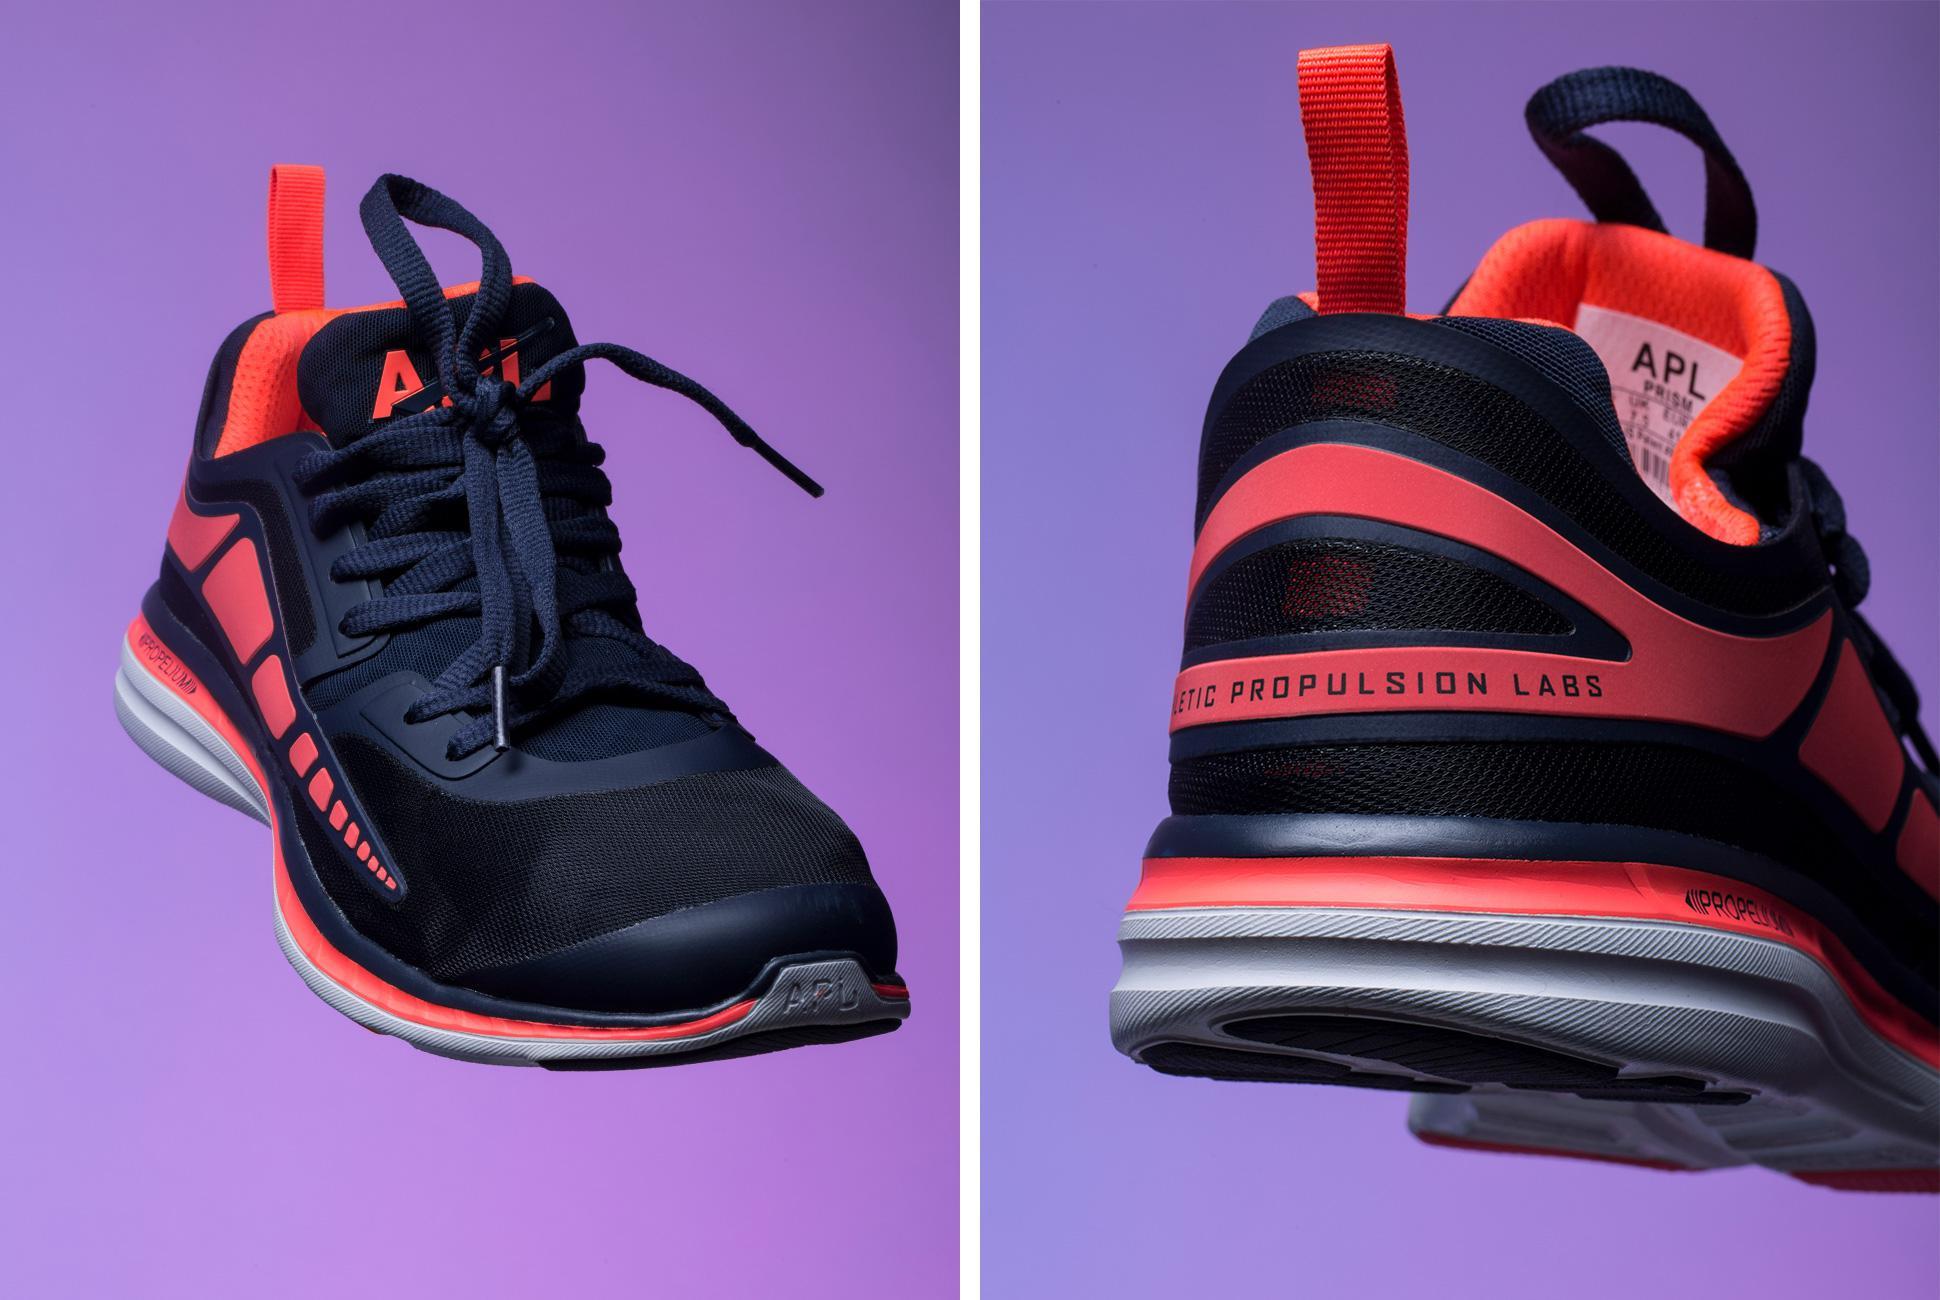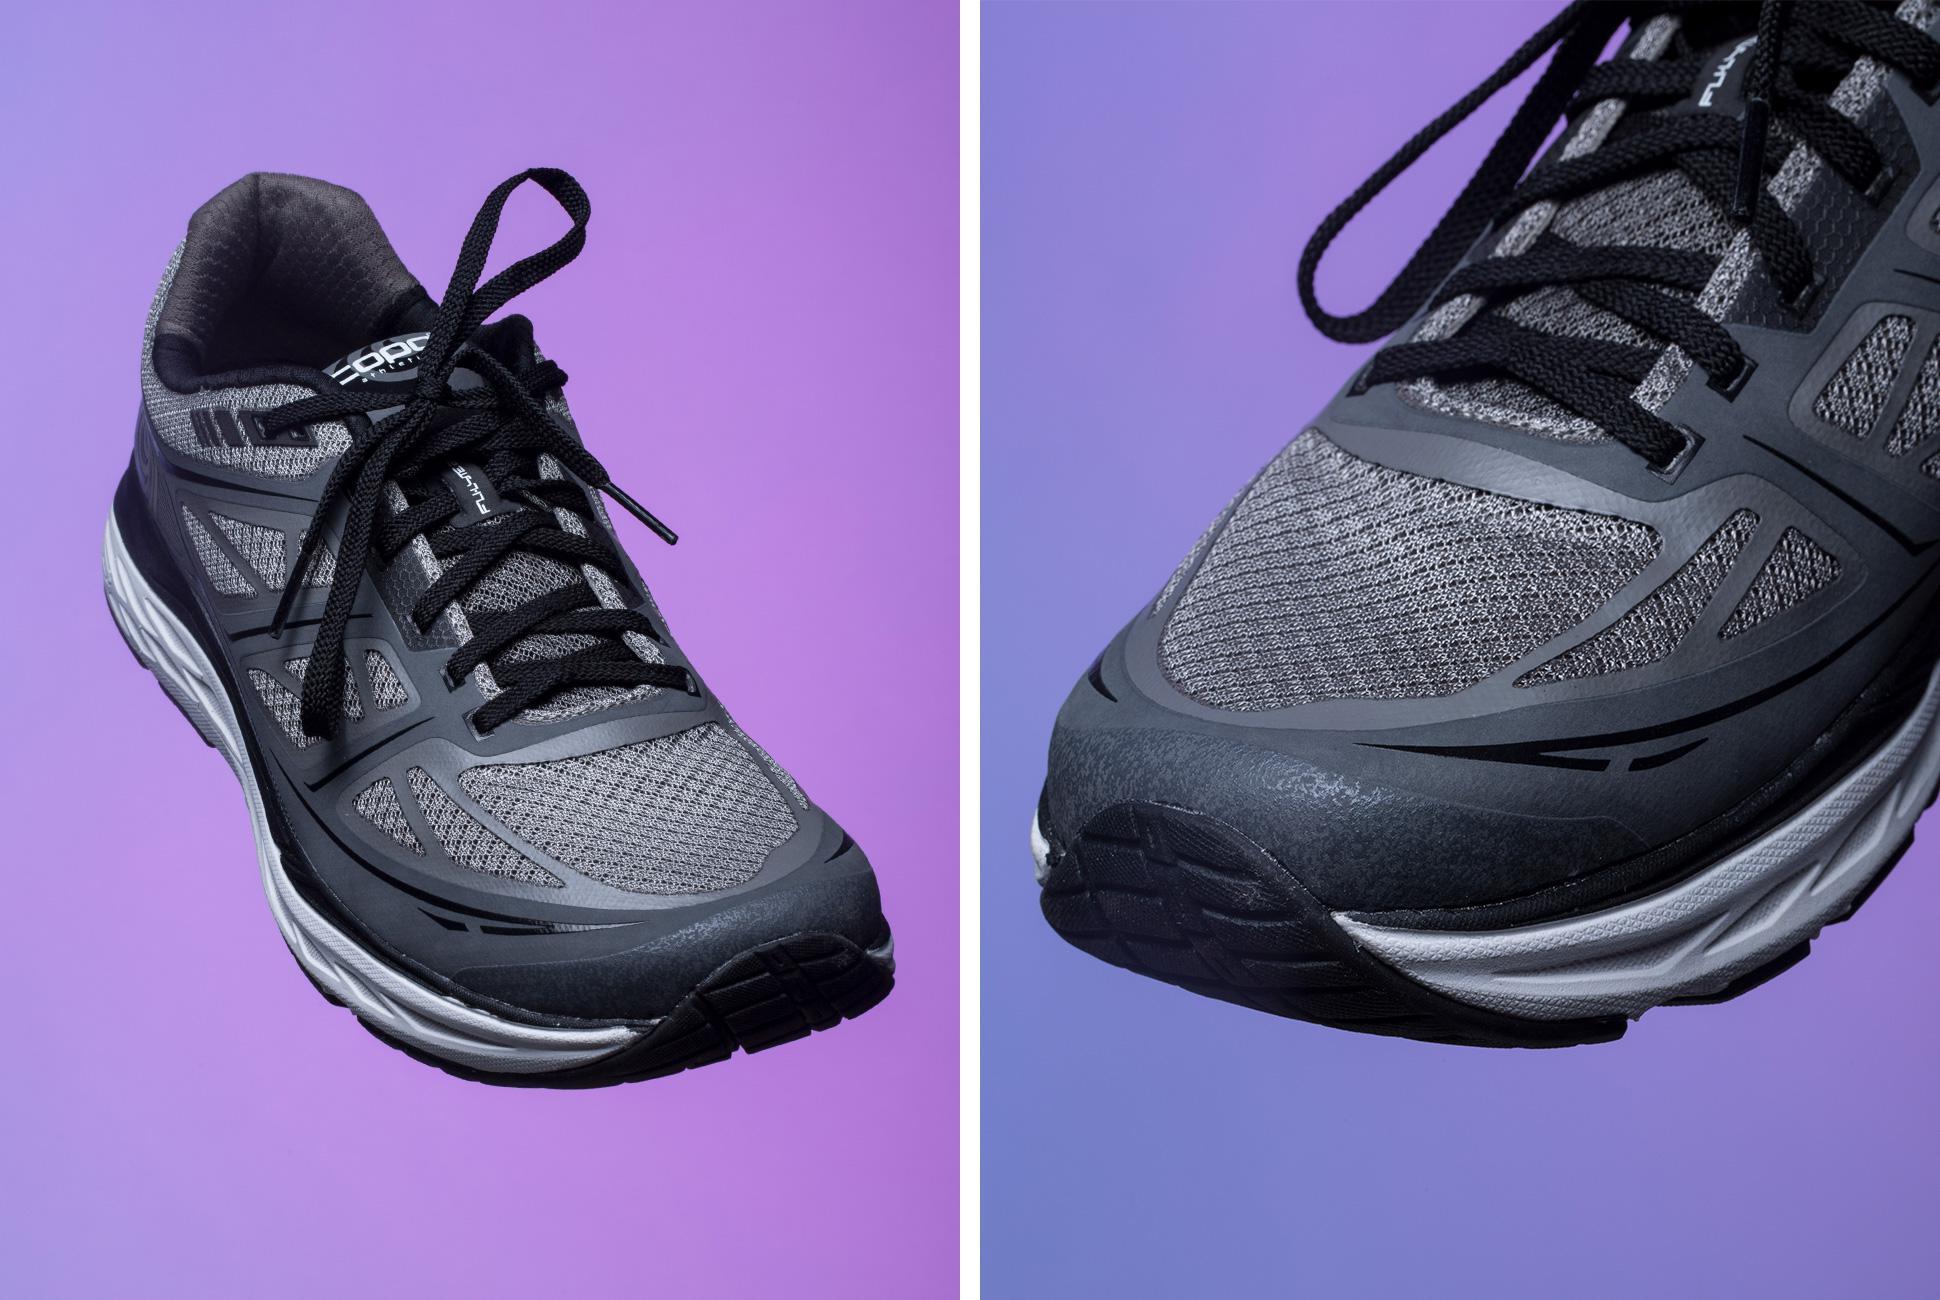The first image is the image on the left, the second image is the image on the right. Assess this claim about the two images: "No more than four sneakers are shown in total, and one sneaker is shown heel-first.". Correct or not? Answer yes or no. Yes. The first image is the image on the left, the second image is the image on the right. Given the left and right images, does the statement "There is a pair of matching shoes in at least one of the images." hold true? Answer yes or no. Yes. 